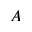Convert formula to latex. <formula><loc_0><loc_0><loc_500><loc_500>A</formula> 